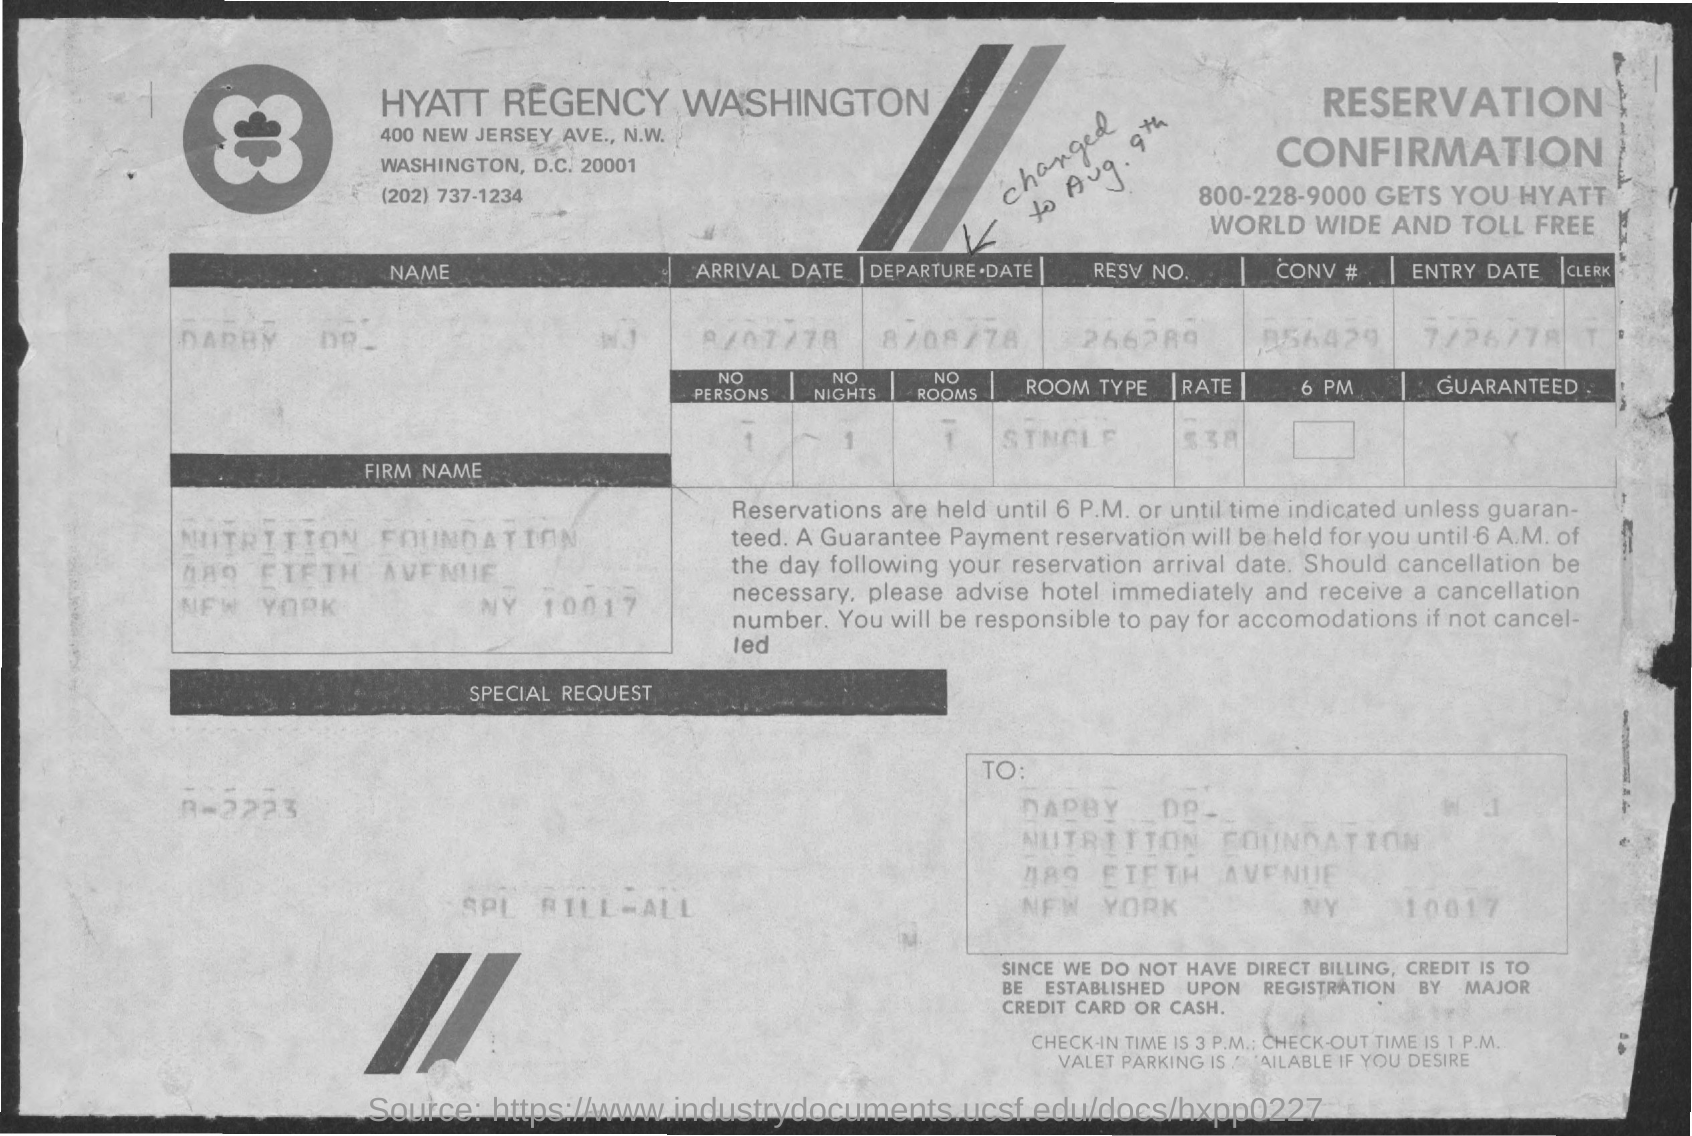What kind of room was reserved according to this document? The reservation was for a single room, as stated under the 'ROOM TYPE' section of the document. Was there a special request made for this reservation? There is a section labeled 'SPECIAL REQUEST,' but it appears to be blank, indicating that no special requests were made for this reservation. 